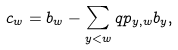Convert formula to latex. <formula><loc_0><loc_0><loc_500><loc_500>c _ { w } = b _ { w } - \sum _ { y < w } q p _ { y , w } b _ { y } ,</formula> 